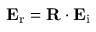<formula> <loc_0><loc_0><loc_500><loc_500>E _ { r } = R \cdot E _ { i }</formula> 